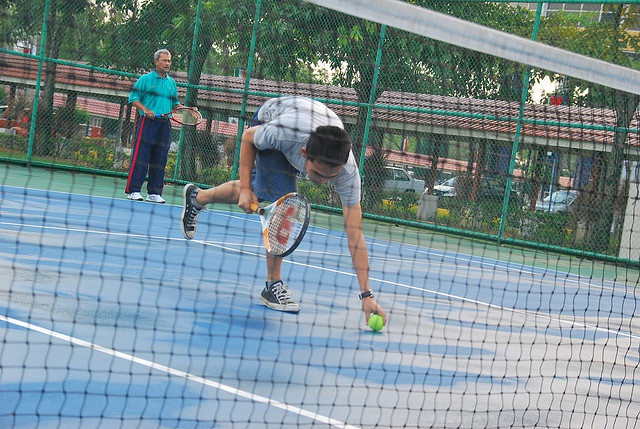Describe the objects in this image and their specific colors. I can see people in black, gray, darkgray, and lightgray tones, people in black, navy, and teal tones, tennis racket in black, darkgray, gray, brown, and lightgray tones, car in black, gray, teal, and lightgray tones, and car in black, gray, darkgray, and teal tones in this image. 